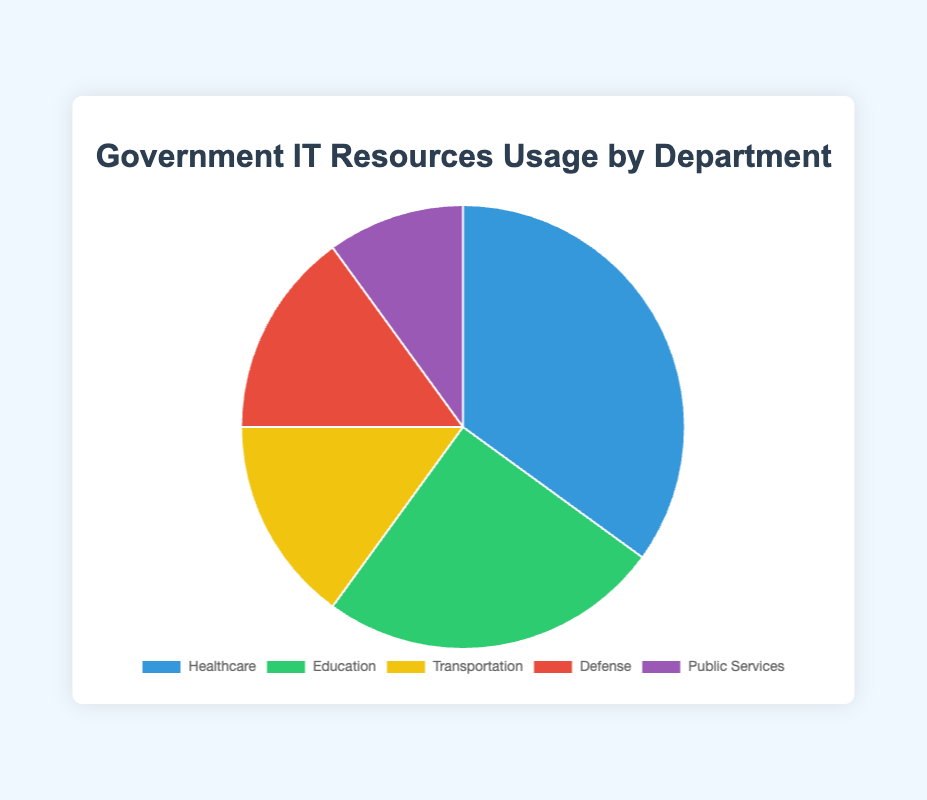How much more do the Healthcare and Education departments use compared to Transportation? Combine the percentages of Healthcare and Education (35% + 25% = 60%) and then subtract the percentage of Transportation (15%) from this combined value (60% - 15% = 45%).
Answer: 45% Which department uses the least IT resources? The Public Services department has the smallest percentage (10%) in the given data.
Answer: Public Services Is the usage of IT resources by Defense equal to that by Transportation? Both Defense and Transportation have the same percentage of IT resource usage (15%).
Answer: Yes What is the combined usage of IT resources by Defense and Public Services? Add the percentages for Defense and Public Services (15% + 10% = 25%).
Answer: 25% Which department uses more IT resources: Education or Transportation? Education uses 25% while Transportation uses 15%, hence Education uses more.
Answer: Education What is the difference in usage between Healthcare and Public Services? Subtract the percentage of Public Services (10%) from Healthcare (35%), giving a difference of (35% - 10% = 25%).
Answer: 25% By how much does Healthcare exceed the combined usage of Defense and Transportation? First, calculate the combined usage of Defense and Transportation (15% + 15% = 30%). Then, subtract this from Healthcare's usage (35% - 30% = 5%).
Answer: 5% Rank the departments in descending order of IT resource usage. The percentages in descending order are: Healthcare (35%), Education (25%), Transportation (15%), Defense (15%), and Public Services (10%).
Answer: Healthcare, Education, Transportation, Defense, Public Services How many departments use 15% or more of the IT resources? Count Healthcare (35%), Education (25%), Transportation (15%), and Defense (15%), giving a total of four departments.
Answer: 4 